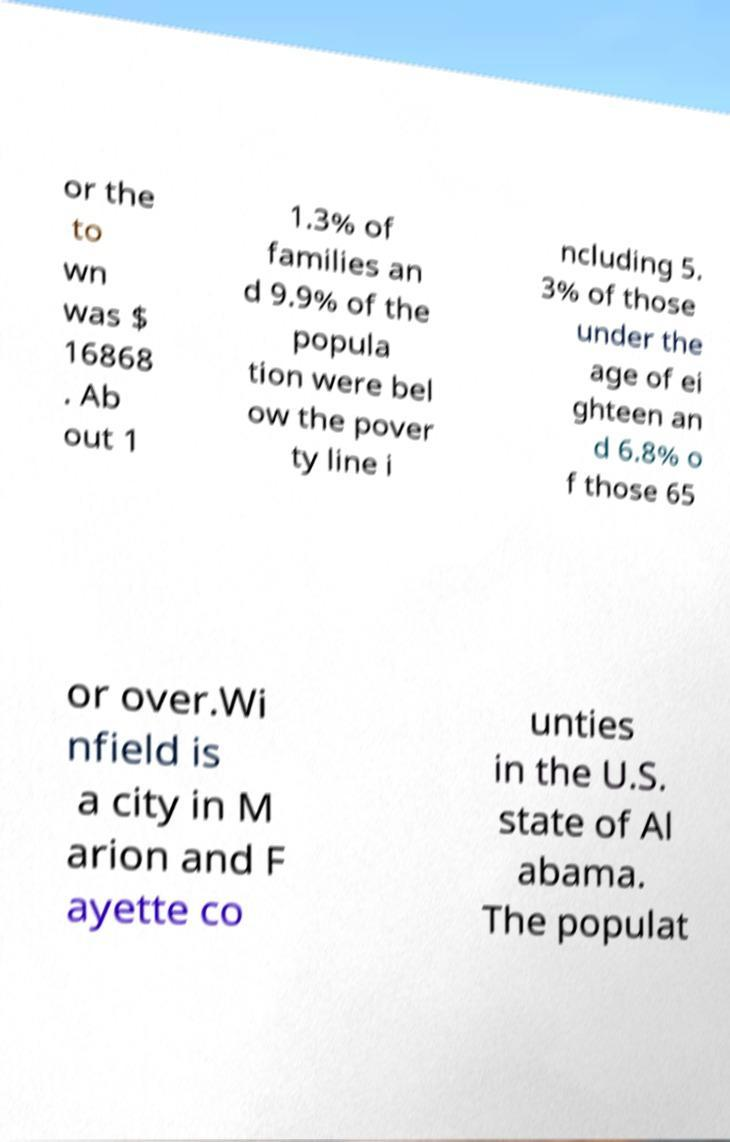Please identify and transcribe the text found in this image. or the to wn was $ 16868 . Ab out 1 1.3% of families an d 9.9% of the popula tion were bel ow the pover ty line i ncluding 5. 3% of those under the age of ei ghteen an d 6.8% o f those 65 or over.Wi nfield is a city in M arion and F ayette co unties in the U.S. state of Al abama. The populat 